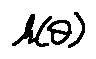Convert formula to latex. <formula><loc_0><loc_0><loc_500><loc_500>h ( \theta )</formula> 